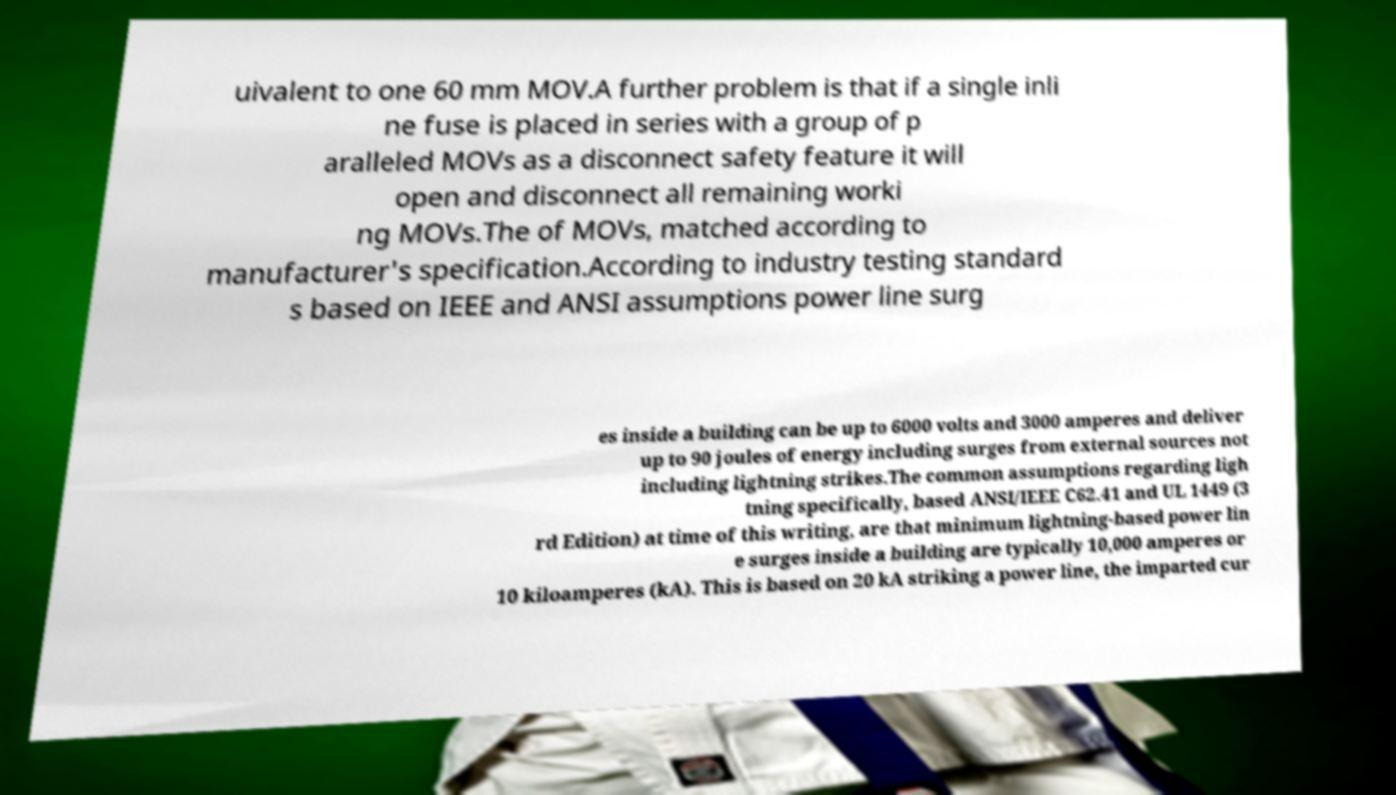There's text embedded in this image that I need extracted. Can you transcribe it verbatim? uivalent to one 60 mm MOV.A further problem is that if a single inli ne fuse is placed in series with a group of p aralleled MOVs as a disconnect safety feature it will open and disconnect all remaining worki ng MOVs.The of MOVs, matched according to manufacturer's specification.According to industry testing standard s based on IEEE and ANSI assumptions power line surg es inside a building can be up to 6000 volts and 3000 amperes and deliver up to 90 joules of energy including surges from external sources not including lightning strikes.The common assumptions regarding ligh tning specifically, based ANSI/IEEE C62.41 and UL 1449 (3 rd Edition) at time of this writing, are that minimum lightning-based power lin e surges inside a building are typically 10,000 amperes or 10 kiloamperes (kA). This is based on 20 kA striking a power line, the imparted cur 